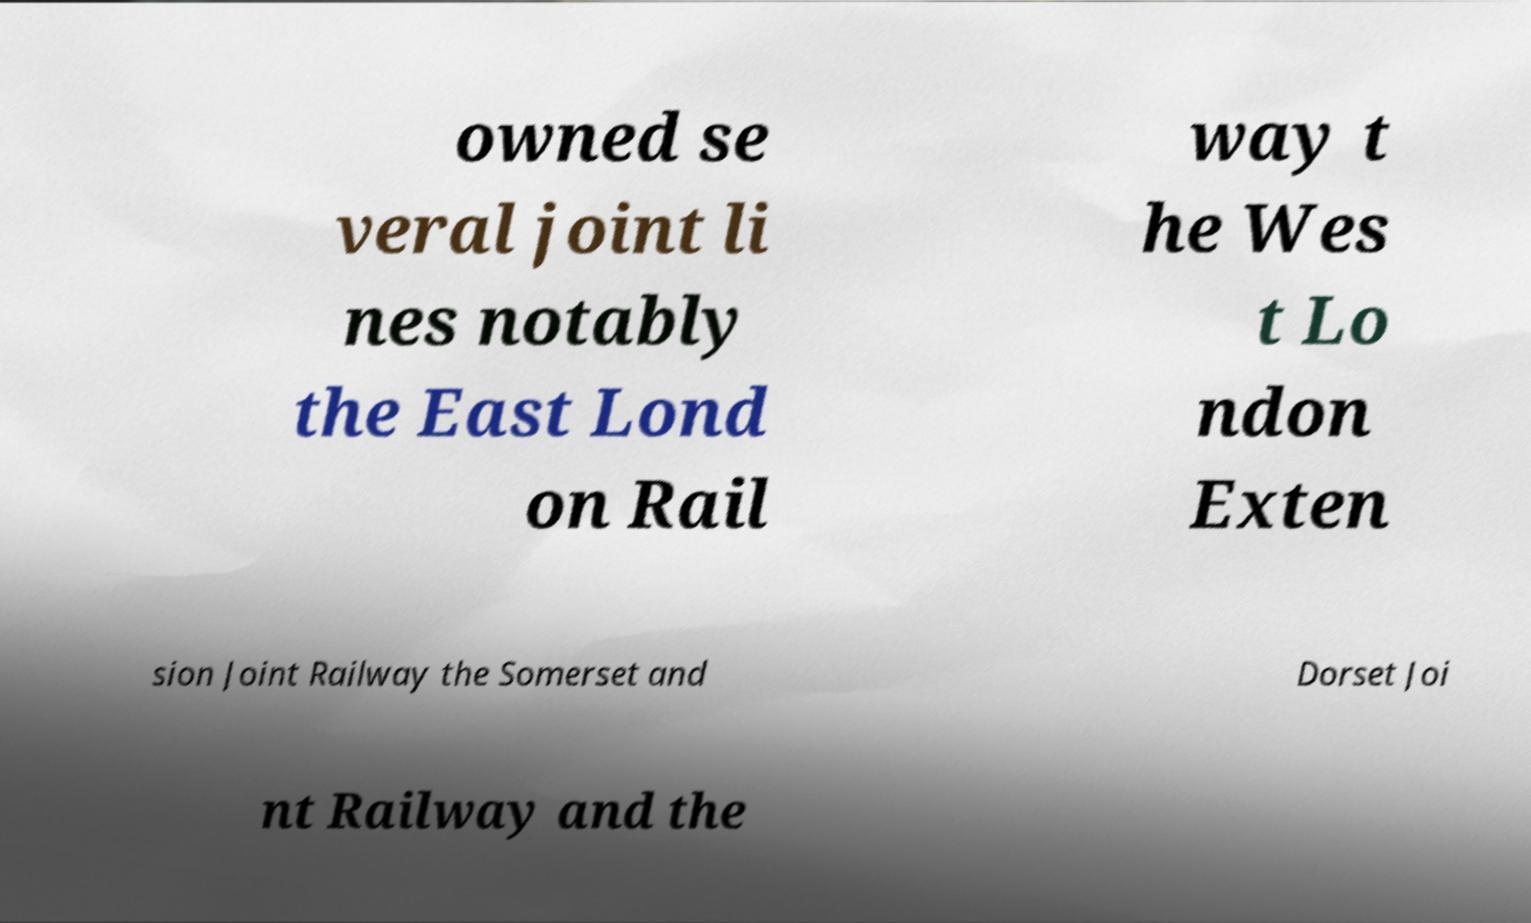Could you assist in decoding the text presented in this image and type it out clearly? owned se veral joint li nes notably the East Lond on Rail way t he Wes t Lo ndon Exten sion Joint Railway the Somerset and Dorset Joi nt Railway and the 